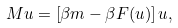<formula> <loc_0><loc_0><loc_500><loc_500>M u = \left [ \beta m - \beta F ( u ) \right ] u ,</formula> 